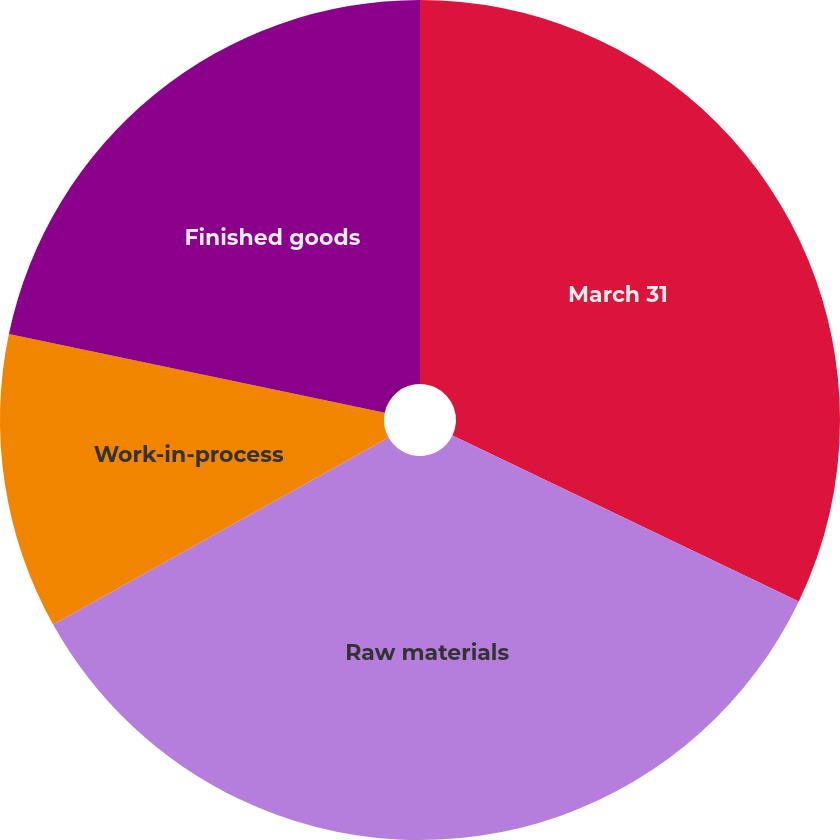Convert chart to OTSL. <chart><loc_0><loc_0><loc_500><loc_500><pie_chart><fcel>March 31<fcel>Raw materials<fcel>Work-in-process<fcel>Finished goods<nl><fcel>32.11%<fcel>34.8%<fcel>11.37%<fcel>21.72%<nl></chart> 